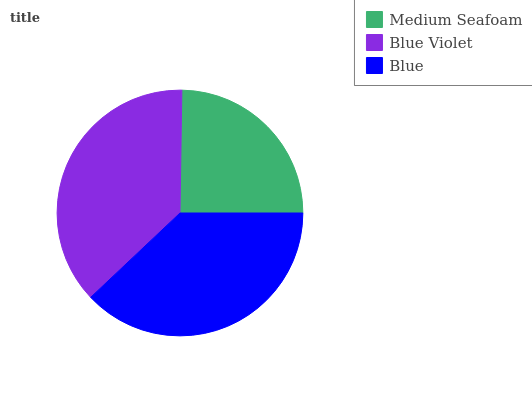Is Medium Seafoam the minimum?
Answer yes or no. Yes. Is Blue the maximum?
Answer yes or no. Yes. Is Blue Violet the minimum?
Answer yes or no. No. Is Blue Violet the maximum?
Answer yes or no. No. Is Blue Violet greater than Medium Seafoam?
Answer yes or no. Yes. Is Medium Seafoam less than Blue Violet?
Answer yes or no. Yes. Is Medium Seafoam greater than Blue Violet?
Answer yes or no. No. Is Blue Violet less than Medium Seafoam?
Answer yes or no. No. Is Blue Violet the high median?
Answer yes or no. Yes. Is Blue Violet the low median?
Answer yes or no. Yes. Is Blue the high median?
Answer yes or no. No. Is Blue the low median?
Answer yes or no. No. 